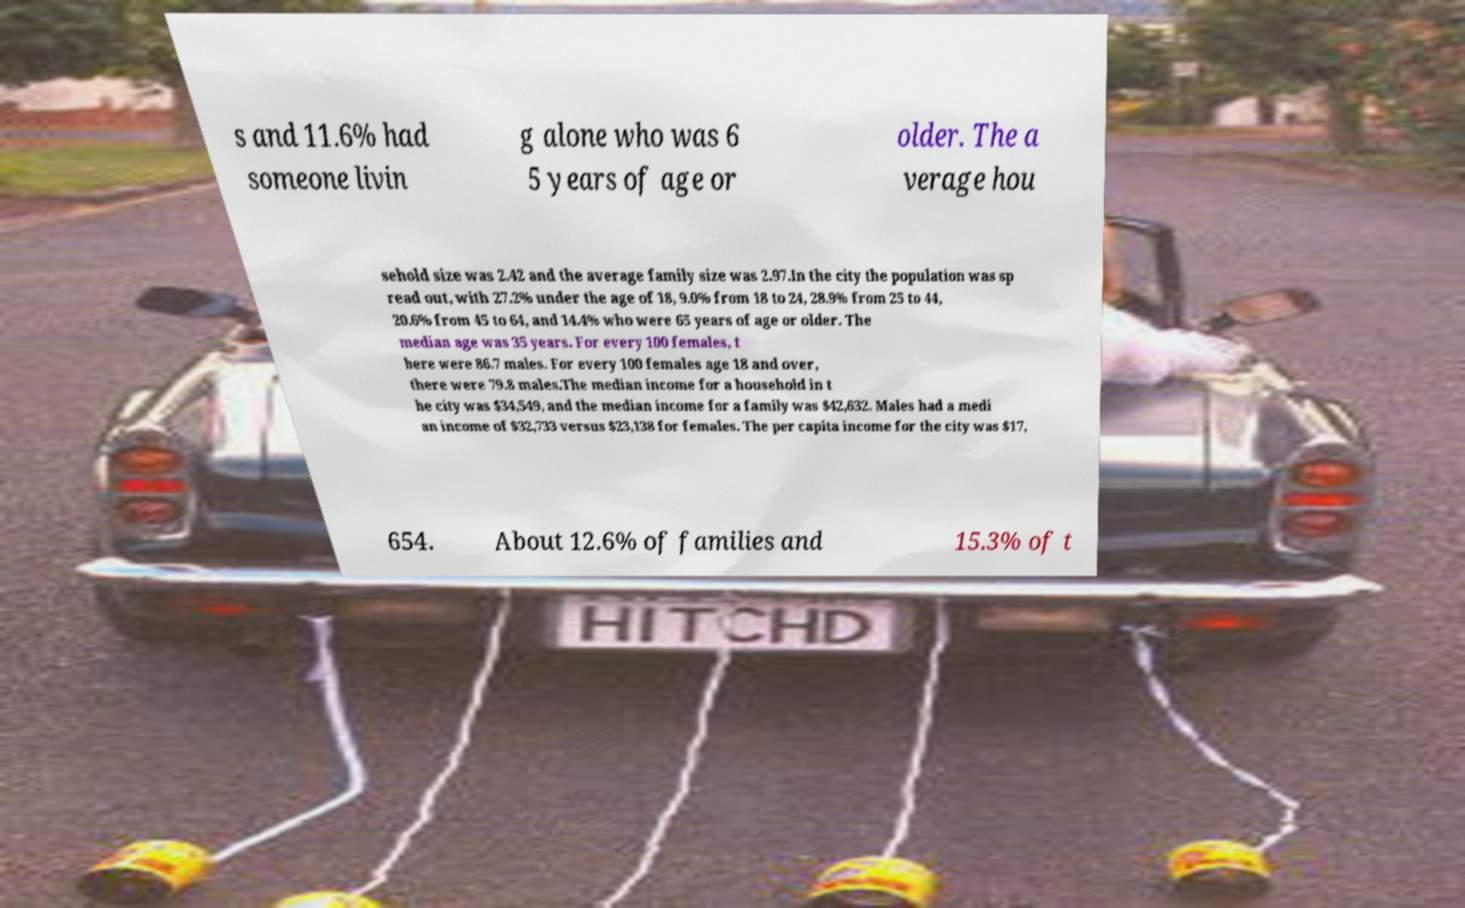There's text embedded in this image that I need extracted. Can you transcribe it verbatim? s and 11.6% had someone livin g alone who was 6 5 years of age or older. The a verage hou sehold size was 2.42 and the average family size was 2.97.In the city the population was sp read out, with 27.2% under the age of 18, 9.0% from 18 to 24, 28.9% from 25 to 44, 20.6% from 45 to 64, and 14.4% who were 65 years of age or older. The median age was 35 years. For every 100 females, t here were 86.7 males. For every 100 females age 18 and over, there were 79.8 males.The median income for a household in t he city was $34,549, and the median income for a family was $42,632. Males had a medi an income of $32,733 versus $23,138 for females. The per capita income for the city was $17, 654. About 12.6% of families and 15.3% of t 